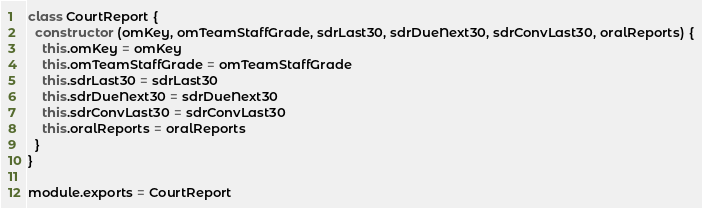Convert code to text. <code><loc_0><loc_0><loc_500><loc_500><_JavaScript_>class CourtReport {
  constructor (omKey, omTeamStaffGrade, sdrLast30, sdrDueNext30, sdrConvLast30, oralReports) {
    this.omKey = omKey
    this.omTeamStaffGrade = omTeamStaffGrade
    this.sdrLast30 = sdrLast30
    this.sdrDueNext30 = sdrDueNext30
    this.sdrConvLast30 = sdrConvLast30
    this.oralReports = oralReports
  }
}

module.exports = CourtReport
</code> 